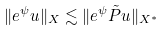Convert formula to latex. <formula><loc_0><loc_0><loc_500><loc_500>\| e ^ { \psi } u \| _ { X } \lesssim \| e ^ { \psi } \tilde { P } u \| _ { X ^ { * } }</formula> 